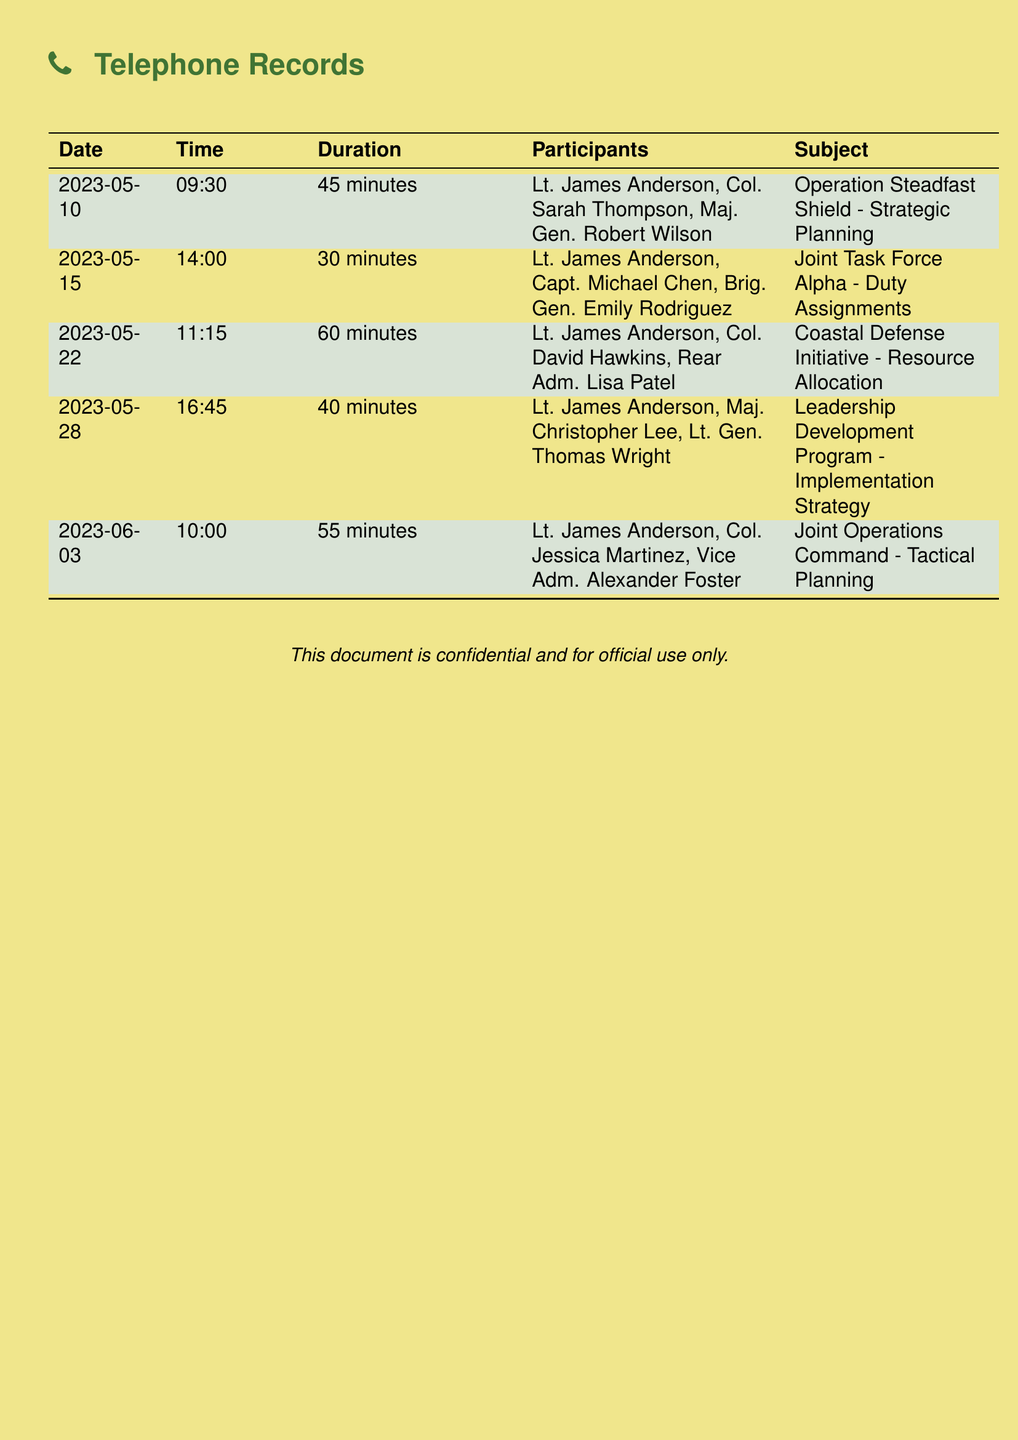What is the longest call duration? The longest call duration is found in the document under the "Duration" column, which is 60 minutes for the call on May 22, 2023.
Answer: 60 minutes Who participated in the call on June 3, 2023? The participants of the call on June 3, 2023, are listed under the "Participants" column: Lt. James Anderson, Col. Jessica Martinez, and Vice Adm. Alexander Foster.
Answer: Lt. James Anderson, Col. Jessica Martinez, Vice Adm. Alexander Foster What was the subject of the call on May 15, 2023? The subject is mentioned in the "Subject" column for the call dated May 15, 2023, which discusses Duty Assignments.
Answer: Duty Assignments How many total conference calls are recorded? The total number of conference calls can be counted from the number of rows in the table provided, which is 5.
Answer: 5 Which official had the highest rank in the call on May 28, 2023? The highest-ranking official in the call on May 28, 2023, can be determined from the "Participants" column, where Lt. Gen. Thomas Wright holds the highest rank.
Answer: Lt. Gen. Thomas Wright What is the date of the call about Operation Steadfast Shield? The date of the call discussing Operation Steadfast Shield is found in the "Date" column, which is May 10, 2023.
Answer: May 10, 2023 What was the topic of discussion during the call on May 22, 2023? The topic is listed in the "Subject" column, which indicates the Coastal Defense Initiative and Resource Allocation.
Answer: Coastal Defense Initiative - Resource Allocation How much time was spent on the call on May 28, 2023? The duration is indicated in the "Duration" column for the call on May 28, 2023, which lasted for 40 minutes.
Answer: 40 minutes 